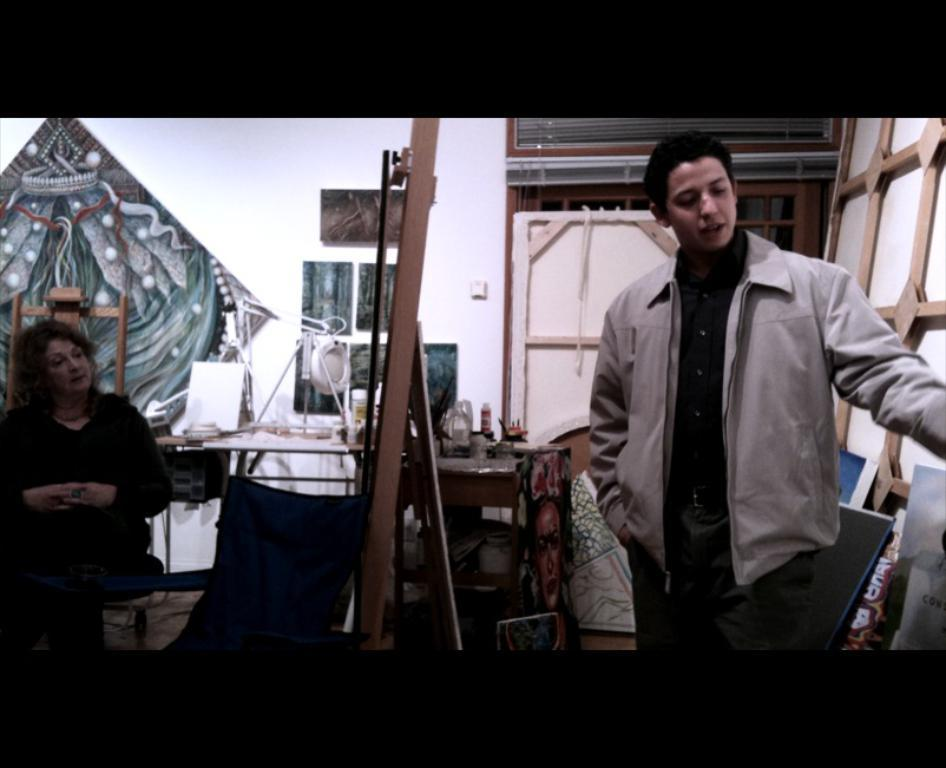How many people are in the image? There are two people in the image. What type of furniture is present in the image? There are chairs and a table in the image. What objects can be seen in the image? There are wooden sticks in the image. What can be seen in the background of the image? There is a wall, frames, and a window in the background of the image. What type of lipstick is the person wearing in the image? There is no lipstick or person wearing lipstick present in the image. How many weeks have passed since the event in the image took place? The image does not depict an event or provide any information about the passage of time, so it is impossible to determine how many weeks have passed. 